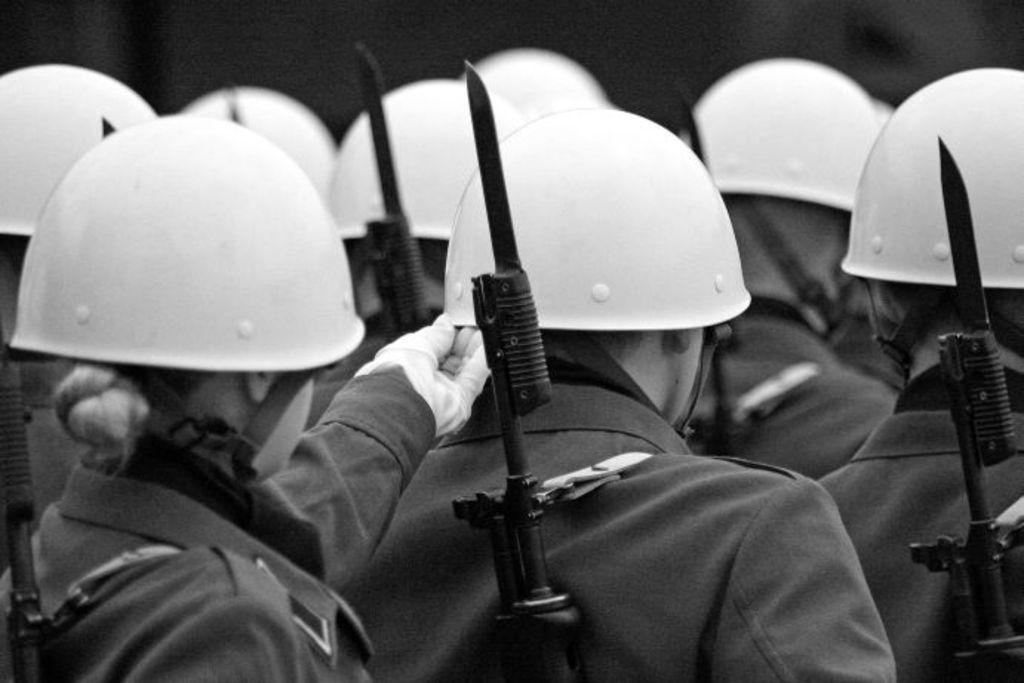What is the color scheme of the image? The image is black and white. What can be seen in the image? There are people in the image. What are the people wearing? The people are wearing uniforms and hats. What are the people holding? The people are holding weapons. In which direction are the people facing? The people are facing towards the back side. What type of wood can be seen floating in the stream in the image? There is no wood or stream present in the image; it features people wearing uniforms, hats, and holding weapons. What kind of leather material is visible on the people's uniforms in the image? There is no mention of leather material in the image; it only states that the people are wearing uniforms. 